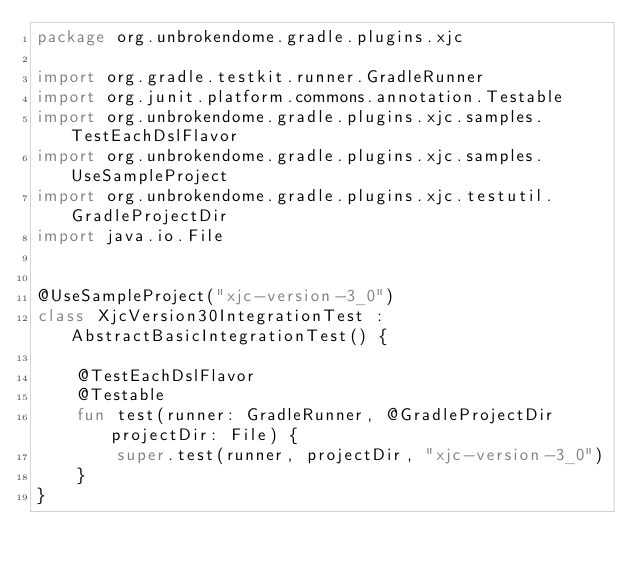<code> <loc_0><loc_0><loc_500><loc_500><_Kotlin_>package org.unbrokendome.gradle.plugins.xjc

import org.gradle.testkit.runner.GradleRunner
import org.junit.platform.commons.annotation.Testable
import org.unbrokendome.gradle.plugins.xjc.samples.TestEachDslFlavor
import org.unbrokendome.gradle.plugins.xjc.samples.UseSampleProject
import org.unbrokendome.gradle.plugins.xjc.testutil.GradleProjectDir
import java.io.File


@UseSampleProject("xjc-version-3_0")
class XjcVersion30IntegrationTest : AbstractBasicIntegrationTest() {

    @TestEachDslFlavor
    @Testable
    fun test(runner: GradleRunner, @GradleProjectDir projectDir: File) {
        super.test(runner, projectDir, "xjc-version-3_0")
    }
}
</code> 